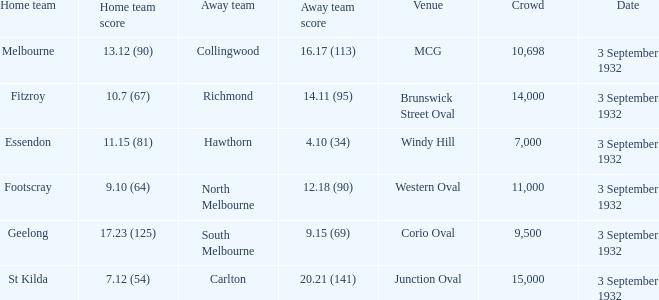18 (90)? 11000.0. 